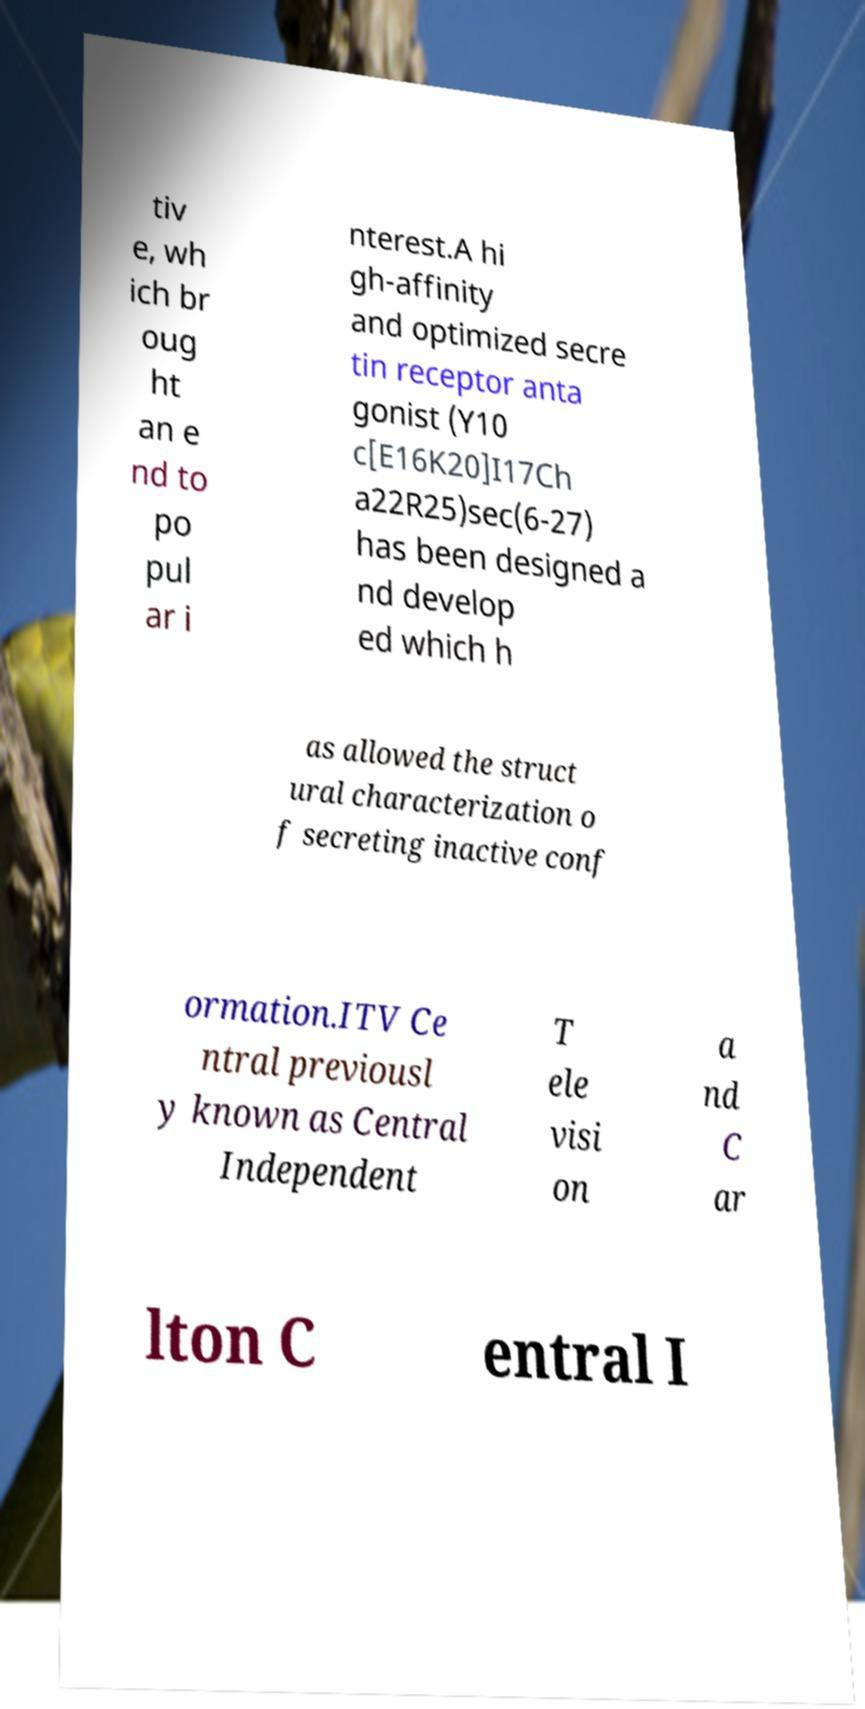Could you assist in decoding the text presented in this image and type it out clearly? tiv e, wh ich br oug ht an e nd to po pul ar i nterest.A hi gh-affinity and optimized secre tin receptor anta gonist (Y10 c[E16K20]I17Ch a22R25)sec(6-27) has been designed a nd develop ed which h as allowed the struct ural characterization o f secreting inactive conf ormation.ITV Ce ntral previousl y known as Central Independent T ele visi on a nd C ar lton C entral I 